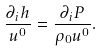Convert formula to latex. <formula><loc_0><loc_0><loc_500><loc_500>\frac { \partial _ { i } h } { u ^ { 0 } } = \frac { \partial _ { i } P } { \rho _ { 0 } u ^ { 0 } } .</formula> 